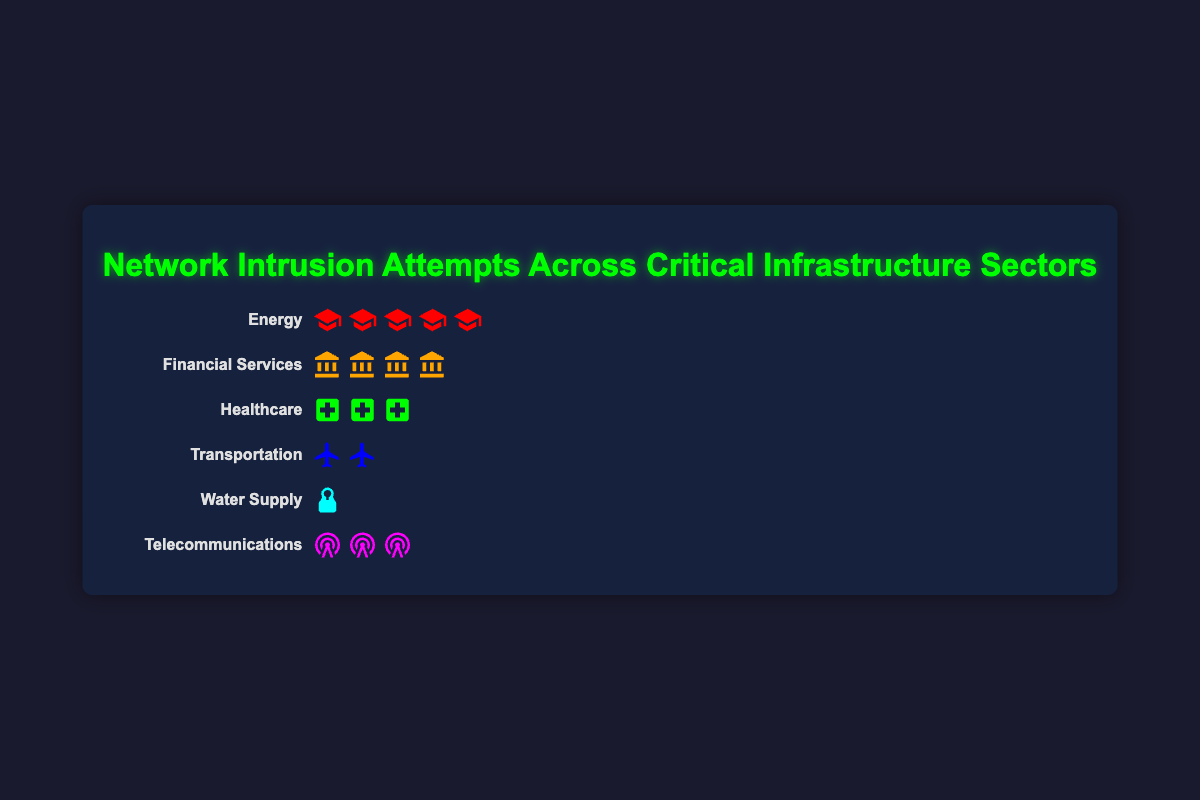what is the title of the plot? The title of the plot is located at the top center and visually distinct with a bright color. The text reads: "Network Intrusion Attempts Across Critical Infrastructure Sectors"
Answer: Network Intrusion Attempts Across Critical Infrastructure Sectors Which sector has the highest number of intrusion attempts? To determine which sector has the highest number of intrusion attempts, count the icons representing each sector. The sector with the most icons is the Energy sector.
Answer: Energy How many sectors have fewer than 100 intrusion attempts? Check the number of icons for each sector and identify those with fewer than 100 attempts. The Healthcare, Transportation, and Water Supply sectors each have fewer than 100 intrusion attempts.
Answer: 3 What is the total number of intrusion attempts represented in the plot? Sum the number of intrusion attempts for each sector: 150 (Energy) + 120 (Financial Services) + 80 (Healthcare) + 60 (Transportation) + 40 (Water Supply) + 90 (Telecommunications) = 540
Answer: 540 How many more intrusion attempts did the Energy sector face compared to the Healthcare sector? Subtract the number of intrusion attempts in the Healthcare sector from those in the Energy sector: 150 (Energy) - 80 (Healthcare) = 70
Answer: 70 What percentage of the total intrusion attempts were aimed at the Telecommunications sector? First, sum the total number of intrusion attempts, which is 540. Then, calculate the percentage: (90 (Telecommunications) / 540) * 100 = 16.67%
Answer: 16.67% Arrange the sectors in descending order based on intrusion attempts. List the intrusion counts for each sector and sort them descending: Energy (150), Financial Services (120), Telecommunications (90), Healthcare (80), Transportation (60), Water Supply (40).
Answer: Energy, Financial Services, Telecommunications, Healthcare, Transportation, Water Supply Which sector has exactly double the number of intrusion attempts as the Water Supply sector? Double the intrusion attempts for the Water Supply sector: 40 * 2 = 80. The Healthcare sector has 80 intrusion attempts.
Answer: Healthcare How many more intrusion attempts does the Financial Services sector have compared to the Telecommunications sector? Subtract the number of intrusion attempts in the Telecommunications sector from those in the Financial Services sector: 120 (Financial Services) - 90 (Telecommunications) = 30
Answer: 30 How does the number of intrusion attempts in the Transportation sector compare to the Telecommunications sector? Compare the number of intrusion attempts: Transportation (60) vs. Telecommunications (90). The Telecommunications sector has more intrusion attempts.
Answer: Telecommunications has more 